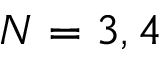Convert formula to latex. <formula><loc_0><loc_0><loc_500><loc_500>N = 3 , 4</formula> 